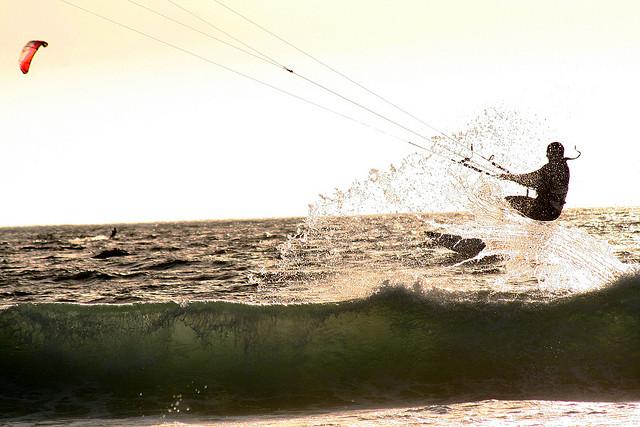Is the surfer male or female?
Be succinct. Male. What color is the wind sail?
Be succinct. Red. What is this person riding in the water?
Write a very short answer. Board. Is the surfer being towed?
Write a very short answer. Yes. 